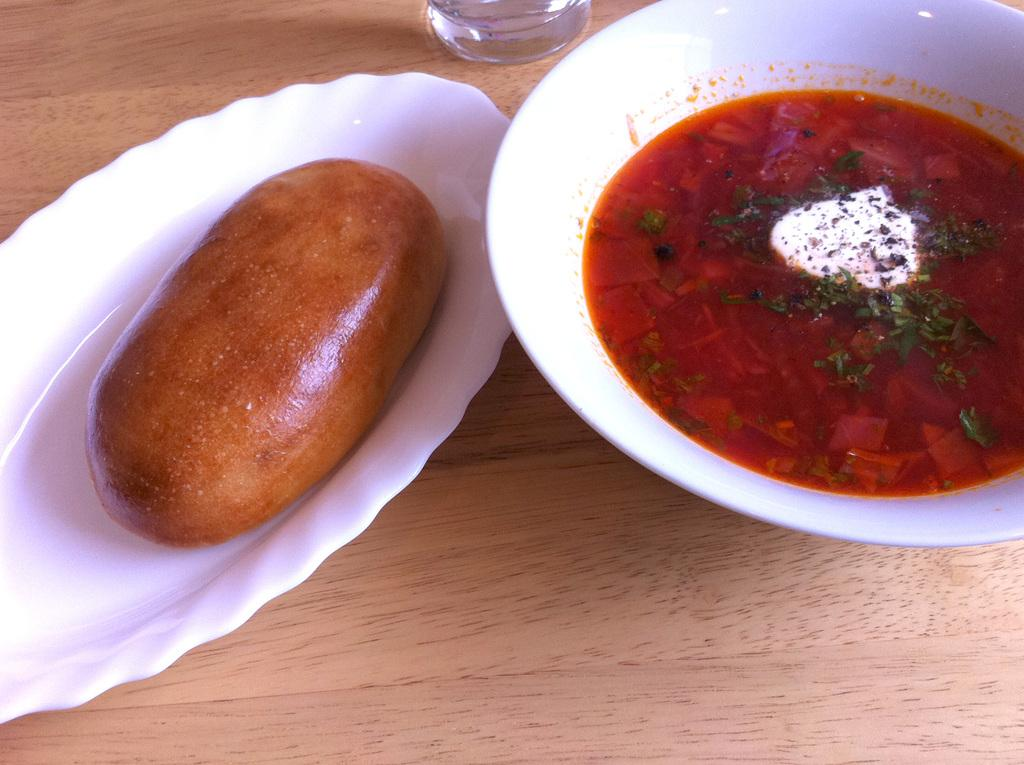What type of food is in the bowl in the image? The facts do not specify the type of food in the bowl. What type of food is on the plate in the image? The facts do not specify the type of food on the plate. Where are the bowl and plate located in the image? The bowl and plate are placed on a table in the image. What is the reaction of the children at the seashore when they see the food in the image? There are no children or seashore present in the image, so it is not possible to determine their reaction to the food. 